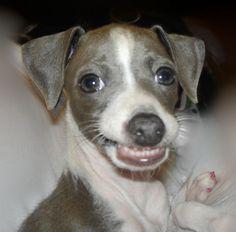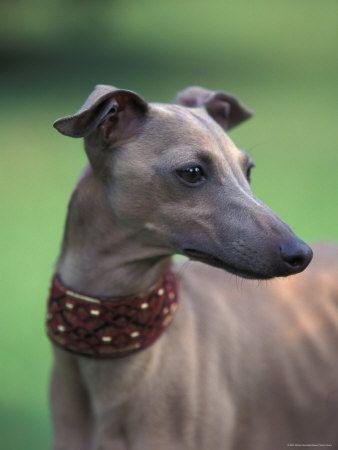The first image is the image on the left, the second image is the image on the right. Analyze the images presented: Is the assertion "The right image shows a gray-and-white dog that is craning its neck." valid? Answer yes or no. No. The first image is the image on the left, the second image is the image on the right. Assess this claim about the two images: "At least one dog is a solid color with no patches of white.". Correct or not? Answer yes or no. Yes. 